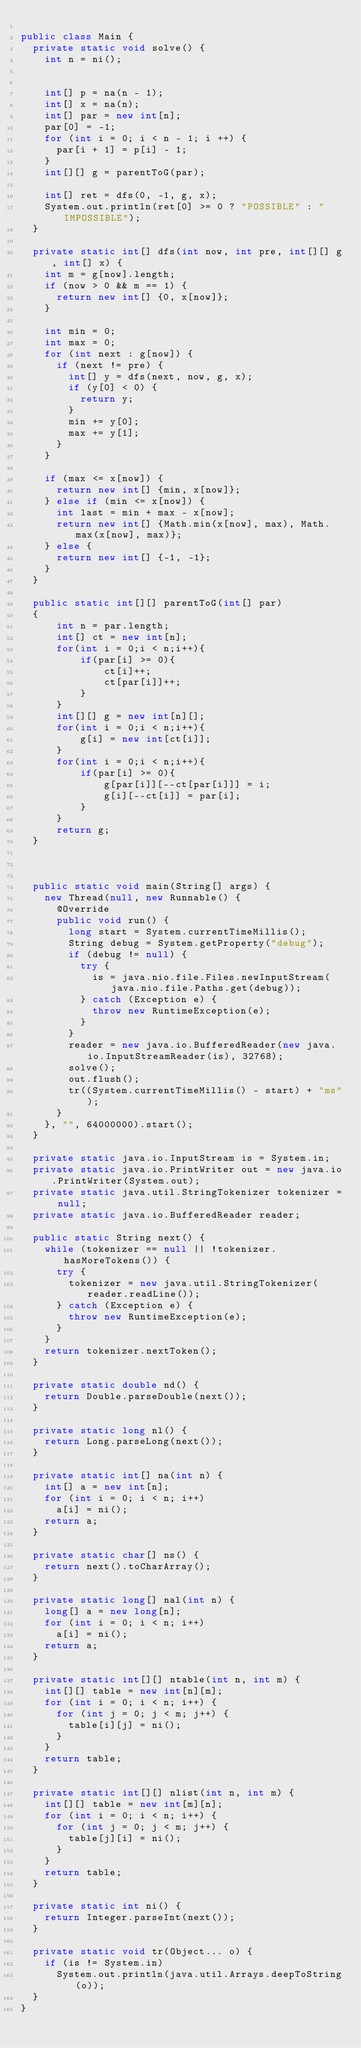<code> <loc_0><loc_0><loc_500><loc_500><_Java_>
public class Main {
  private static void solve() {
    int n = ni();
    
    
    int[] p = na(n - 1);
    int[] x = na(n);
    int[] par = new int[n];
    par[0] = -1;
    for (int i = 0; i < n - 1; i ++) {
      par[i + 1] = p[i] - 1;
    }
    int[][] g = parentToG(par);
    
    int[] ret = dfs(0, -1, g, x);
    System.out.println(ret[0] >= 0 ? "POSSIBLE" : "IMPOSSIBLE");
  }
  
  private static int[] dfs(int now, int pre, int[][] g, int[] x) {
    int m = g[now].length;
    if (now > 0 && m == 1) {
      return new int[] {0, x[now]};
    }

    int min = 0;
    int max = 0;
    for (int next : g[now]) {
      if (next != pre) {
        int[] y = dfs(next, now, g, x);
        if (y[0] < 0) {
          return y;
        }
        min += y[0];
        max += y[1];
      }
    }
    
    if (max <= x[now]) {
      return new int[] {min, x[now]};
    } else if (min <= x[now]) {
      int last = min + max - x[now];
      return new int[] {Math.min(x[now], max), Math.max(x[now], max)};
    } else {
      return new int[] {-1, -1};
    }
  }
  
  public static int[][] parentToG(int[] par)
  {
      int n = par.length;
      int[] ct = new int[n];
      for(int i = 0;i < n;i++){
          if(par[i] >= 0){
              ct[i]++;
              ct[par[i]]++;
          }
      }
      int[][] g = new int[n][];
      for(int i = 0;i < n;i++){
          g[i] = new int[ct[i]];
      }
      for(int i = 0;i < n;i++){
          if(par[i] >= 0){
              g[par[i]][--ct[par[i]]] = i;
              g[i][--ct[i]] = par[i];
          }
      }
      return g;
  }
  


  public static void main(String[] args) {
    new Thread(null, new Runnable() {
      @Override
      public void run() {
        long start = System.currentTimeMillis();
        String debug = System.getProperty("debug");
        if (debug != null) {
          try {
            is = java.nio.file.Files.newInputStream(java.nio.file.Paths.get(debug));
          } catch (Exception e) {
            throw new RuntimeException(e);
          }
        }
        reader = new java.io.BufferedReader(new java.io.InputStreamReader(is), 32768);
        solve();
        out.flush();
        tr((System.currentTimeMillis() - start) + "ms");
      }
    }, "", 64000000).start();
  }

  private static java.io.InputStream is = System.in;
  private static java.io.PrintWriter out = new java.io.PrintWriter(System.out);
  private static java.util.StringTokenizer tokenizer = null;
  private static java.io.BufferedReader reader;

  public static String next() {
    while (tokenizer == null || !tokenizer.hasMoreTokens()) {
      try {
        tokenizer = new java.util.StringTokenizer(reader.readLine());
      } catch (Exception e) {
        throw new RuntimeException(e);
      }
    }
    return tokenizer.nextToken();
  }

  private static double nd() {
    return Double.parseDouble(next());
  }

  private static long nl() {
    return Long.parseLong(next());
  }

  private static int[] na(int n) {
    int[] a = new int[n];
    for (int i = 0; i < n; i++)
      a[i] = ni();
    return a;
  }

  private static char[] ns() {
    return next().toCharArray();
  }

  private static long[] nal(int n) {
    long[] a = new long[n];
    for (int i = 0; i < n; i++)
      a[i] = ni();
    return a;
  }

  private static int[][] ntable(int n, int m) {
    int[][] table = new int[n][m];
    for (int i = 0; i < n; i++) {
      for (int j = 0; j < m; j++) {
        table[i][j] = ni();
      }
    }
    return table;
  }

  private static int[][] nlist(int n, int m) {
    int[][] table = new int[m][n];
    for (int i = 0; i < n; i++) {
      for (int j = 0; j < m; j++) {
        table[j][i] = ni();
      }
    }
    return table;
  }

  private static int ni() {
    return Integer.parseInt(next());
  }

  private static void tr(Object... o) {
    if (is != System.in)
      System.out.println(java.util.Arrays.deepToString(o));
  }
}


</code> 